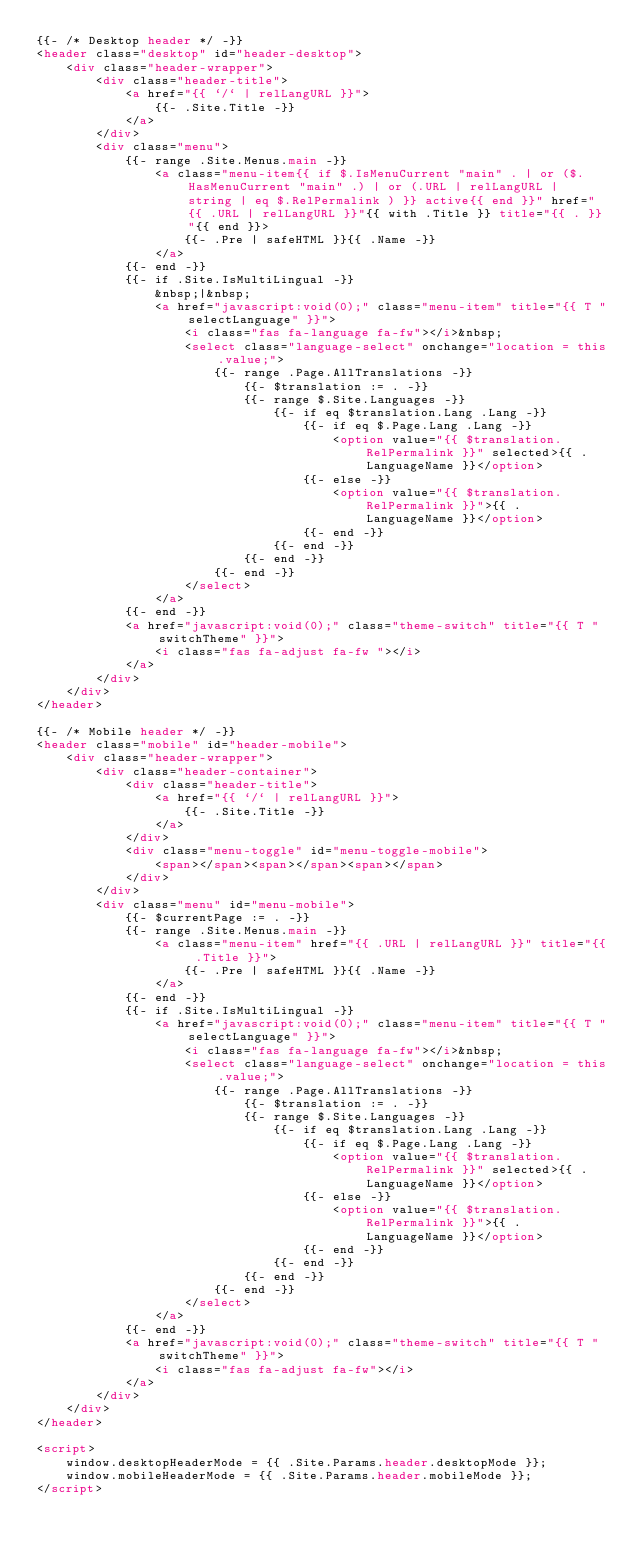<code> <loc_0><loc_0><loc_500><loc_500><_HTML_>{{- /* Desktop header */ -}}
<header class="desktop" id="header-desktop">
    <div class="header-wrapper">
        <div class="header-title">
            <a href="{{ `/` | relLangURL }}">
                {{- .Site.Title -}}
            </a>
        </div>
        <div class="menu">
            {{- range .Site.Menus.main -}}
                <a class="menu-item{{ if $.IsMenuCurrent "main" . | or ($.HasMenuCurrent "main" .) | or (.URL | relLangURL | string | eq $.RelPermalink ) }} active{{ end }}" href="{{ .URL | relLangURL }}"{{ with .Title }} title="{{ . }}"{{ end }}>
                    {{- .Pre | safeHTML }}{{ .Name -}}
                </a>
            {{- end -}}
            {{- if .Site.IsMultiLingual -}}
                &nbsp;|&nbsp;
                <a href="javascript:void(0);" class="menu-item" title="{{ T "selectLanguage" }}">
                    <i class="fas fa-language fa-fw"></i>&nbsp;
                    <select class="language-select" onchange="location = this.value;">
                        {{- range .Page.AllTranslations -}}
                            {{- $translation := . -}}
                            {{- range $.Site.Languages -}}
                                {{- if eq $translation.Lang .Lang -}}
                                    {{- if eq $.Page.Lang .Lang -}}
                                        <option value="{{ $translation.RelPermalink }}" selected>{{ .LanguageName }}</option>
                                    {{- else -}}
                                        <option value="{{ $translation.RelPermalink }}">{{ .LanguageName }}</option>
                                    {{- end -}}
                                {{- end -}}
                            {{- end -}}
                        {{- end -}}
                    </select>
                </a>
            {{- end -}}
            <a href="javascript:void(0);" class="theme-switch" title="{{ T "switchTheme" }}">
                <i class="fas fa-adjust fa-fw "></i>
            </a>
        </div>
    </div>
</header>

{{- /* Mobile header */ -}}
<header class="mobile" id="header-mobile">
    <div class="header-wrapper">
        <div class="header-container">
            <div class="header-title">
                <a href="{{ `/` | relLangURL }}">
                    {{- .Site.Title -}}
                </a>
            </div>
            <div class="menu-toggle" id="menu-toggle-mobile">
                <span></span><span></span><span></span>
            </div>
        </div>
        <div class="menu" id="menu-mobile">
            {{- $currentPage := . -}}
            {{- range .Site.Menus.main -}}
                <a class="menu-item" href="{{ .URL | relLangURL }}" title="{{ .Title }}">
                    {{- .Pre | safeHTML }}{{ .Name -}}
                </a>
            {{- end -}}
            {{- if .Site.IsMultiLingual -}}
                <a href="javascript:void(0);" class="menu-item" title="{{ T "selectLanguage" }}">
                    <i class="fas fa-language fa-fw"></i>&nbsp;
                    <select class="language-select" onchange="location = this.value;">
                        {{- range .Page.AllTranslations -}}
                            {{- $translation := . -}}
                            {{- range $.Site.Languages -}}
                                {{- if eq $translation.Lang .Lang -}}
                                    {{- if eq $.Page.Lang .Lang -}}
                                        <option value="{{ $translation.RelPermalink }}" selected>{{ .LanguageName }}</option>
                                    {{- else -}}
                                        <option value="{{ $translation.RelPermalink }}">{{ .LanguageName }}</option>
                                    {{- end -}}
                                {{- end -}}
                            {{- end -}}
                        {{- end -}}
                    </select>
                </a>
            {{- end -}}
            <a href="javascript:void(0);" class="theme-switch" title="{{ T "switchTheme" }}">
                <i class="fas fa-adjust fa-fw"></i>
            </a>
        </div>
    </div>
</header>

<script>
    window.desktopHeaderMode = {{ .Site.Params.header.desktopMode }};
    window.mobileHeaderMode = {{ .Site.Params.header.mobileMode }};
</script>
</code> 